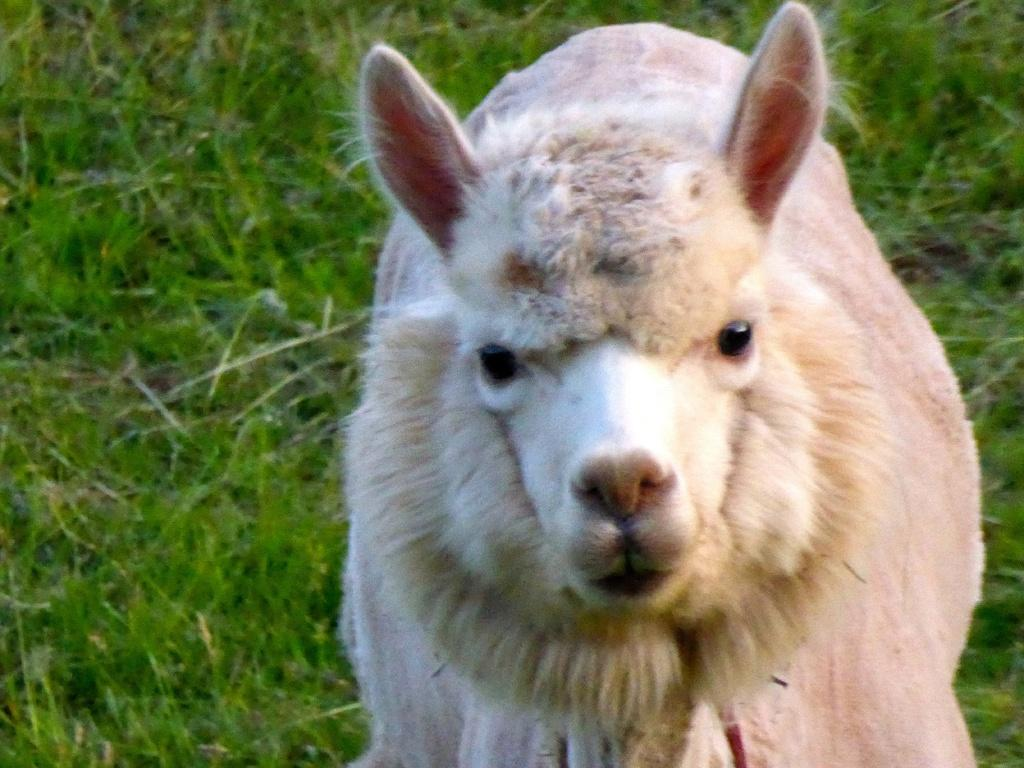What type of animal is on the right side of the image? The specific type of animal cannot be determined from the provided facts. What can be seen on the ground in the background of the image? There is grass on the ground in the background of the image. What type of pollution can be seen in the image? There is no indication of pollution in the image. What discovery was made by the animal in the image? There is no indication of a discovery made by the animal in the image. 